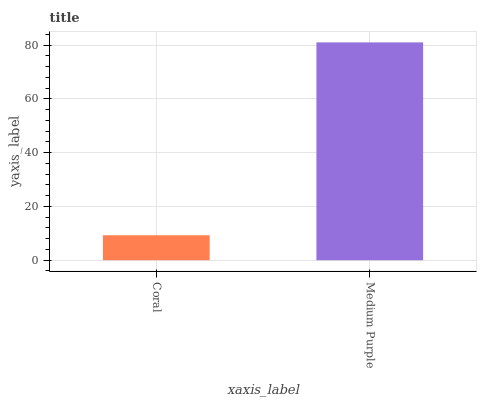Is Medium Purple the minimum?
Answer yes or no. No. Is Medium Purple greater than Coral?
Answer yes or no. Yes. Is Coral less than Medium Purple?
Answer yes or no. Yes. Is Coral greater than Medium Purple?
Answer yes or no. No. Is Medium Purple less than Coral?
Answer yes or no. No. Is Medium Purple the high median?
Answer yes or no. Yes. Is Coral the low median?
Answer yes or no. Yes. Is Coral the high median?
Answer yes or no. No. Is Medium Purple the low median?
Answer yes or no. No. 